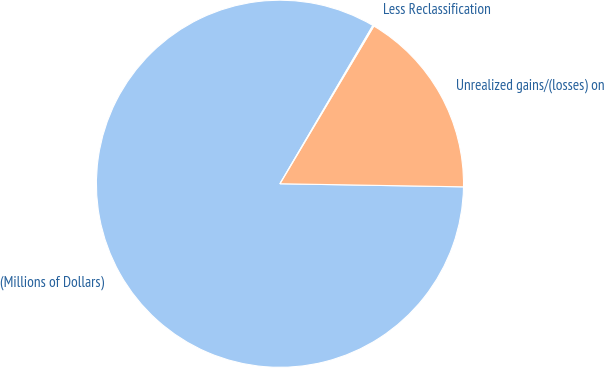<chart> <loc_0><loc_0><loc_500><loc_500><pie_chart><fcel>(Millions of Dollars)<fcel>Unrealized gains/(losses) on<fcel>Less Reclassification<nl><fcel>83.18%<fcel>16.72%<fcel>0.1%<nl></chart> 